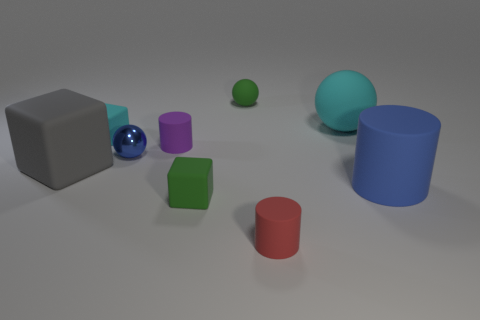Subtract all small spheres. How many spheres are left? 1 Subtract all cylinders. How many objects are left? 6 Subtract 1 spheres. How many spheres are left? 2 Add 2 large gray objects. How many large gray objects are left? 3 Add 1 green balls. How many green balls exist? 2 Subtract 0 blue cubes. How many objects are left? 9 Subtract all purple cylinders. Subtract all yellow cubes. How many cylinders are left? 2 Subtract all brown cylinders. How many cyan cubes are left? 1 Subtract all big cyan balls. Subtract all big cyan metal cylinders. How many objects are left? 8 